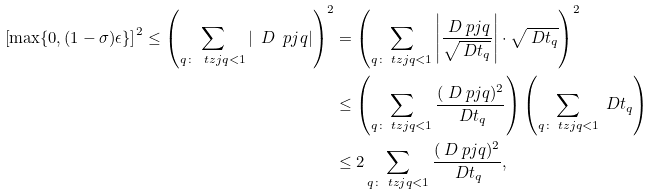Convert formula to latex. <formula><loc_0><loc_0><loc_500><loc_500>\left [ \max \{ 0 , ( 1 - \sigma ) \epsilon \} \right ] ^ { 2 } \leq \left ( \sum _ { q \colon \ t z j q < 1 } | \ D \ p j q | \right ) ^ { 2 } & = \left ( \sum _ { q \colon \ t z j q < 1 } \left | \frac { \ D \ p j q } { \sqrt { \ D t _ { q } } } \right | \cdot \sqrt { \ D t _ { q } } \right ) ^ { 2 } \\ & \leq \left ( \sum _ { q \colon \ t z j q < 1 } \frac { ( \ D \ p j q ) ^ { 2 } } { \ D t _ { q } } \right ) \left ( \sum _ { q \colon \ t z j q < 1 } \ D t _ { q } \right ) \\ & \leq 2 \sum _ { q \colon \ t z j q < 1 } \frac { ( \ D \ p j q ) ^ { 2 } } { \ D t _ { q } } ,</formula> 